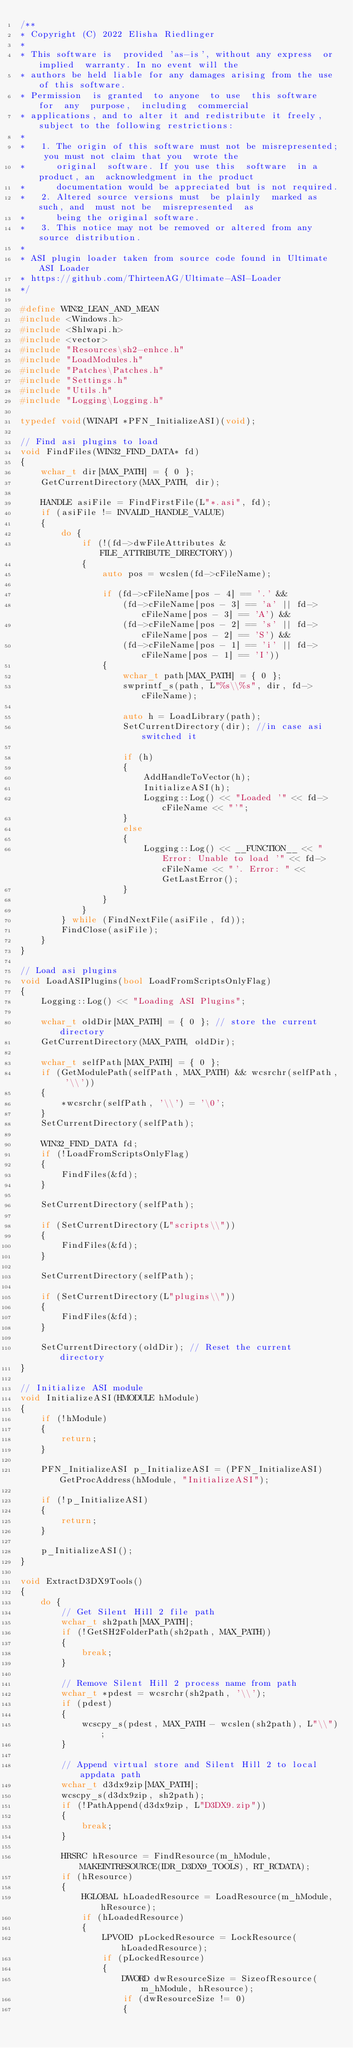Convert code to text. <code><loc_0><loc_0><loc_500><loc_500><_C++_>/**
* Copyright (C) 2022 Elisha Riedlinger
*
* This software is  provided 'as-is', without any express  or implied  warranty. In no event will the
* authors be held liable for any damages arising from the use of this software.
* Permission  is granted  to anyone  to use  this software  for  any  purpose,  including  commercial
* applications, and to alter it and redistribute it freely, subject to the following restrictions:
*
*   1. The origin of this software must not be misrepresented; you must not claim that you  wrote the
*      original  software. If you use this  software  in a product, an  acknowledgment in the product
*      documentation would be appreciated but is not required.
*   2. Altered source versions must  be plainly  marked as such, and  must not be  misrepresented  as
*      being the original software.
*   3. This notice may not be removed or altered from any source distribution.
*
* ASI plugin loader taken from source code found in Ultimate ASI Loader
* https://github.com/ThirteenAG/Ultimate-ASI-Loader
*/

#define WIN32_LEAN_AND_MEAN
#include <Windows.h>
#include <Shlwapi.h>
#include <vector>
#include "Resources\sh2-enhce.h"
#include "LoadModules.h"
#include "Patches\Patches.h"
#include "Settings.h"
#include "Utils.h"
#include "Logging\Logging.h"

typedef void(WINAPI *PFN_InitializeASI)(void);

// Find asi plugins to load
void FindFiles(WIN32_FIND_DATA* fd)
{
	wchar_t dir[MAX_PATH] = { 0 };
	GetCurrentDirectory(MAX_PATH, dir);

	HANDLE asiFile = FindFirstFile(L"*.asi", fd);
	if (asiFile != INVALID_HANDLE_VALUE)
	{
		do {
			if (!(fd->dwFileAttributes & FILE_ATTRIBUTE_DIRECTORY))
			{
				auto pos = wcslen(fd->cFileName);

				if (fd->cFileName[pos - 4] == '.' &&
					(fd->cFileName[pos - 3] == 'a' || fd->cFileName[pos - 3] == 'A') &&
					(fd->cFileName[pos - 2] == 's' || fd->cFileName[pos - 2] == 'S') &&
					(fd->cFileName[pos - 1] == 'i' || fd->cFileName[pos - 1] == 'I'))
				{
					wchar_t path[MAX_PATH] = { 0 };
					swprintf_s(path, L"%s\\%s", dir, fd->cFileName);

					auto h = LoadLibrary(path);
					SetCurrentDirectory(dir); //in case asi switched it

					if (h)
					{
						AddHandleToVector(h);
						InitializeASI(h);
						Logging::Log() << "Loaded '" << fd->cFileName << "'";
					}
					else
					{
						Logging::Log() << __FUNCTION__ << " Error: Unable to load '" << fd->cFileName << "'. Error: " << GetLastError();
					}
				}
			}
		} while (FindNextFile(asiFile, fd));
		FindClose(asiFile);
	}
}

// Load asi plugins
void LoadASIPlugins(bool LoadFromScriptsOnlyFlag)
{
	Logging::Log() << "Loading ASI Plugins";

	wchar_t oldDir[MAX_PATH] = { 0 }; // store the current directory
	GetCurrentDirectory(MAX_PATH, oldDir);

	wchar_t selfPath[MAX_PATH] = { 0 };
	if (GetModulePath(selfPath, MAX_PATH) && wcsrchr(selfPath, '\\'))
	{
		*wcsrchr(selfPath, '\\') = '\0';
	}
	SetCurrentDirectory(selfPath);

	WIN32_FIND_DATA fd;
	if (!LoadFromScriptsOnlyFlag)
	{
		FindFiles(&fd);
	}

	SetCurrentDirectory(selfPath);

	if (SetCurrentDirectory(L"scripts\\"))
	{
		FindFiles(&fd);
	}

	SetCurrentDirectory(selfPath);

	if (SetCurrentDirectory(L"plugins\\"))
	{
		FindFiles(&fd);
	}

	SetCurrentDirectory(oldDir); // Reset the current directory
}

// Initialize ASI module
void InitializeASI(HMODULE hModule)
{
	if (!hModule)
	{
		return;
	}

	PFN_InitializeASI p_InitializeASI = (PFN_InitializeASI)GetProcAddress(hModule, "InitializeASI");

	if (!p_InitializeASI)
	{
		return;
	}

	p_InitializeASI();
}

void ExtractD3DX9Tools()
{
	do {
		// Get Silent Hill 2 file path
		wchar_t sh2path[MAX_PATH];
		if (!GetSH2FolderPath(sh2path, MAX_PATH))
		{
			break;
		}

		// Remove Silent Hill 2 process name from path
		wchar_t *pdest = wcsrchr(sh2path, '\\');
		if (pdest)
		{
			wcscpy_s(pdest, MAX_PATH - wcslen(sh2path), L"\\");
		}

		// Append virtual store and Silent Hill 2 to local appdata path
		wchar_t d3dx9zip[MAX_PATH];
		wcscpy_s(d3dx9zip, sh2path);
		if (!PathAppend(d3dx9zip, L"D3DX9.zip"))
		{
			break;
		}

		HRSRC hResource = FindResource(m_hModule, MAKEINTRESOURCE(IDR_D3DX9_TOOLS), RT_RCDATA);
		if (hResource)
		{
			HGLOBAL hLoadedResource = LoadResource(m_hModule, hResource);
			if (hLoadedResource)
			{
				LPVOID pLockedResource = LockResource(hLoadedResource);
				if (pLockedResource)
				{
					DWORD dwResourceSize = SizeofResource(m_hModule, hResource);
					if (dwResourceSize != 0)
					{</code> 